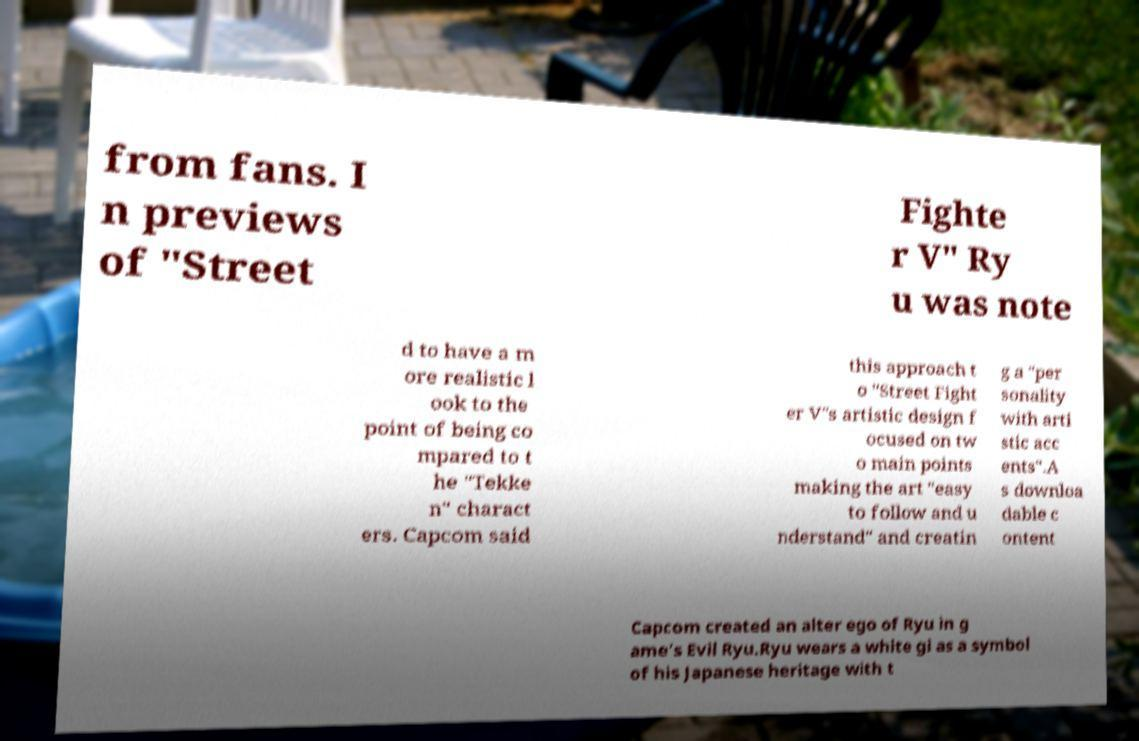For documentation purposes, I need the text within this image transcribed. Could you provide that? from fans. I n previews of "Street Fighte r V" Ry u was note d to have a m ore realistic l ook to the point of being co mpared to t he "Tekke n" charact ers. Capcom said this approach t o "Street Fight er V"s artistic design f ocused on tw o main points making the art "easy to follow and u nderstand" and creatin g a "per sonality with arti stic acc ents".A s downloa dable c ontent Capcom created an alter ego of Ryu in g ame's Evil Ryu.Ryu wears a white gi as a symbol of his Japanese heritage with t 